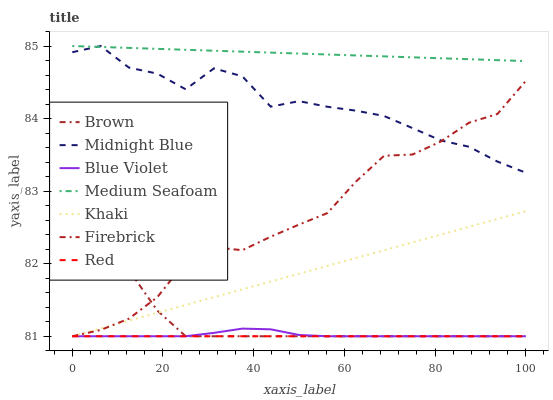Does Red have the minimum area under the curve?
Answer yes or no. Yes. Does Medium Seafoam have the maximum area under the curve?
Answer yes or no. Yes. Does Khaki have the minimum area under the curve?
Answer yes or no. No. Does Khaki have the maximum area under the curve?
Answer yes or no. No. Is Red the smoothest?
Answer yes or no. Yes. Is Midnight Blue the roughest?
Answer yes or no. Yes. Is Khaki the smoothest?
Answer yes or no. No. Is Khaki the roughest?
Answer yes or no. No. Does Brown have the lowest value?
Answer yes or no. Yes. Does Midnight Blue have the lowest value?
Answer yes or no. No. Does Medium Seafoam have the highest value?
Answer yes or no. Yes. Does Khaki have the highest value?
Answer yes or no. No. Is Firebrick less than Medium Seafoam?
Answer yes or no. Yes. Is Midnight Blue greater than Brown?
Answer yes or no. Yes. Does Blue Violet intersect Firebrick?
Answer yes or no. Yes. Is Blue Violet less than Firebrick?
Answer yes or no. No. Is Blue Violet greater than Firebrick?
Answer yes or no. No. Does Firebrick intersect Medium Seafoam?
Answer yes or no. No. 